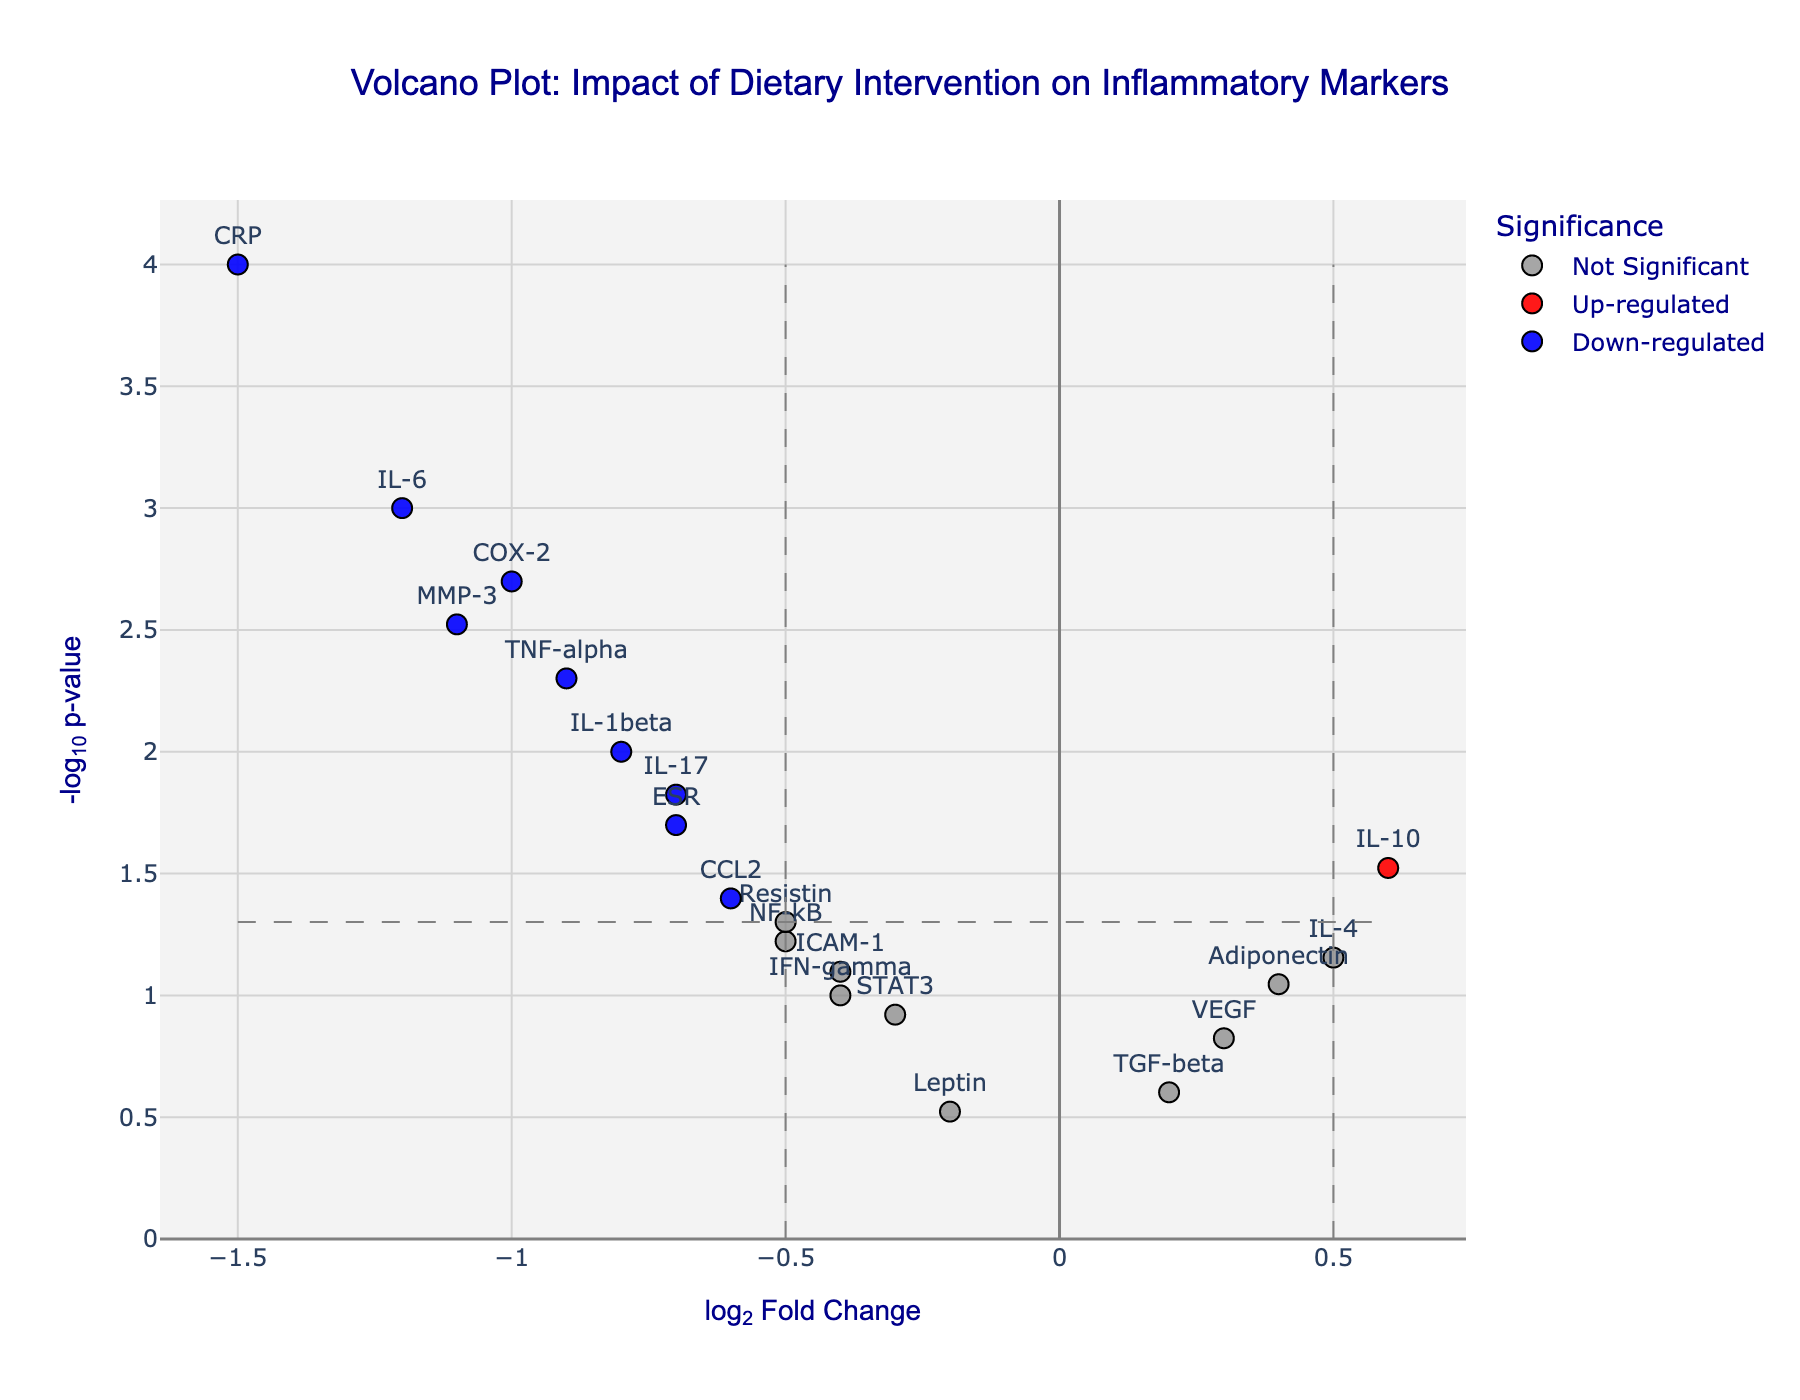What is the title of the Volcano Plot? The title is located at the top of the figure in bold text and it reads "Volcano Plot: Impact of Dietary Intervention on Inflammatory Markers".
Answer: Volcano Plot: Impact of Dietary Intervention on Inflammatory Markers How many data points are classified as 'Down-regulated'? Points classified as 'Down-regulated' are plotted in blue. Count these blue points to find the number of 'Down-regulated' genes.
Answer: 7 Which gene has the most significant down-regulated change? Most significant down-regulated change means the lowest p-value with the highest absolute log2FoldChange in the negative axis (left). IL-6, -1.5.
Answer: CRP Which gene has the least significant change? The least significant change corresponds to the gene with the highest p-value (lowest -log10(p-value)).
Answer: TGF-beta What are the x-axis and y-axis labels? The x-axis and y-axis labels are usually displayed below and to the left of the respective axes, and they read "log2 Fold Change" and "-log10 p-value".
Answer: log2 Fold Change and -log10 p-value Identify genes that are 'Up-regulated'. Genes that are 'Up-regulated' are plotted in red. The names of the red points (genes) need to be identified.
Answer: IL-10 and IL-4 What is the -log10(p-value) threshold for significance? The -log10(p-value) threshold is determined by the horizontal dashed gray line corresponding to a p-value of 0.05. Calculate -log10(0.05) approximately.
Answer: 1.3 Compare IL-6 and TNF-alpha in terms of log2FoldChange and significance level. IL-6 has a log2FoldChange of -1.2 and a p-value of 0.001. TNF-alpha has a log2FoldChange of -0.9 and a p-value of 0.005. So, IL-6 has a higher absolute log2FoldChange (more negative) and is more significant (lower p-value).
Answer: IL-6: -1.2, 0.001; TNF-alpha: -0.9, 0.005 Name one gene that is neither up-regulated nor down-regulated but still significant. Genes that are categorized as 'Significant' but not 'Up-regulated' or 'Down-regulated' will be plotted in orange and will have log2FoldChange within ±0.5. Find these points.
Answer: CCL2 